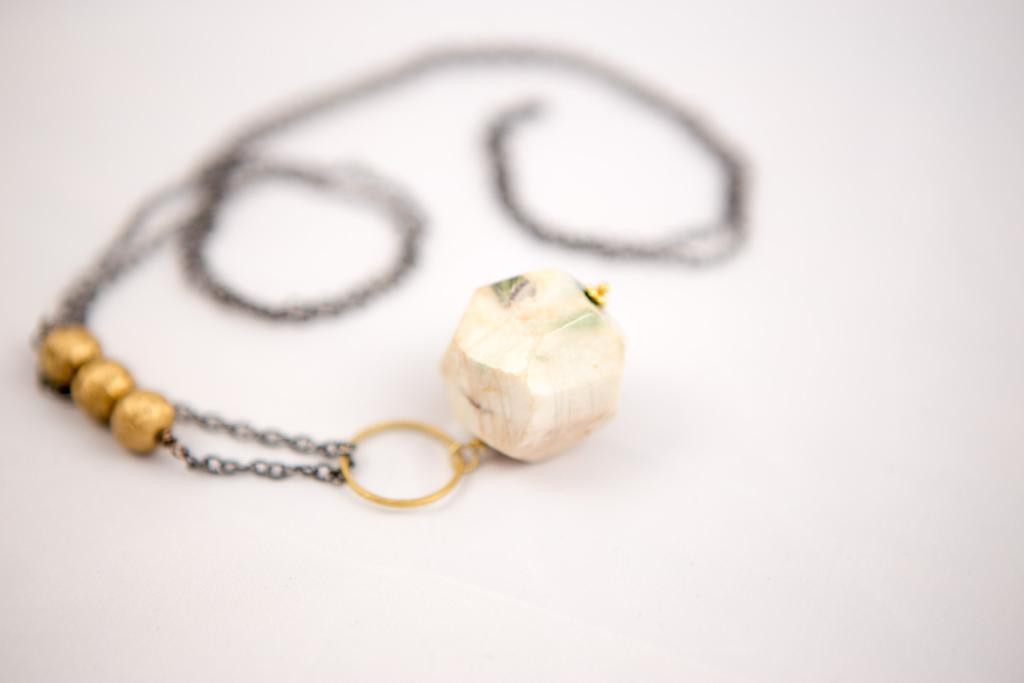What is the main object in the center of the image? There is a chain in the center of the image. What is attached to the chain? There is a pendant attached to the chain. How many mittens are present in the image? There are no mittens present in the image. 